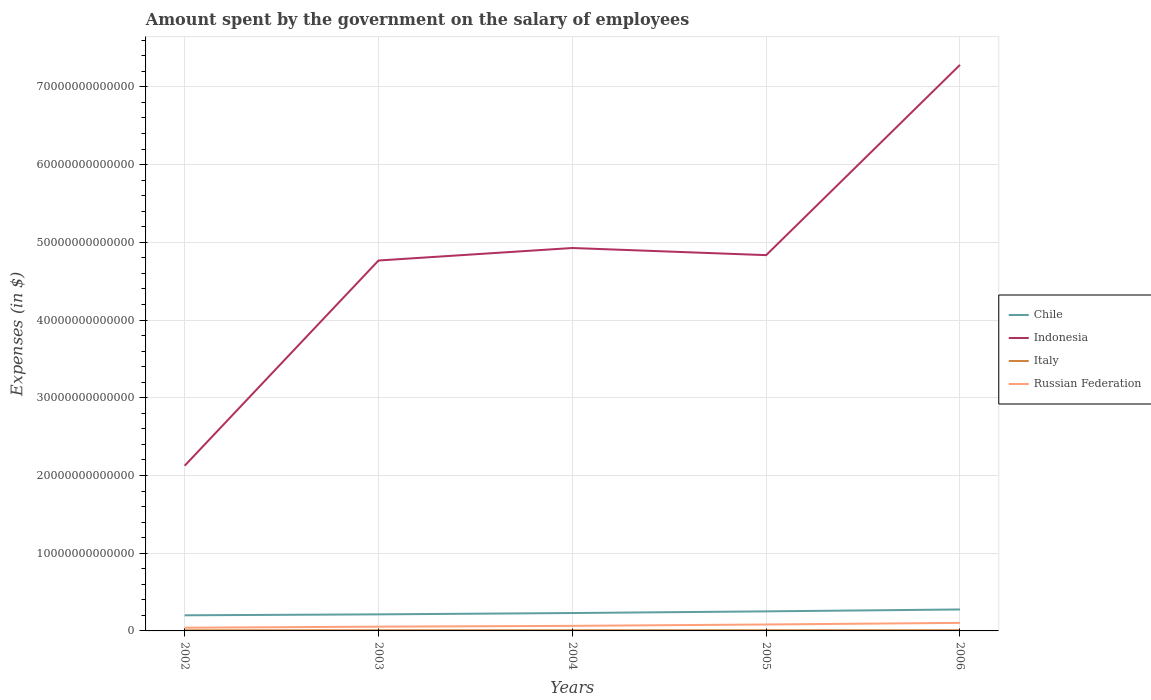How many different coloured lines are there?
Offer a terse response. 4. Does the line corresponding to Russian Federation intersect with the line corresponding to Indonesia?
Provide a short and direct response. No. Is the number of lines equal to the number of legend labels?
Provide a short and direct response. Yes. Across all years, what is the maximum amount spent on the salary of employees by the government in Chile?
Ensure brevity in your answer.  2.01e+12. In which year was the amount spent on the salary of employees by the government in Chile maximum?
Your answer should be compact. 2002. What is the total amount spent on the salary of employees by the government in Russian Federation in the graph?
Your answer should be compact. -4.15e+11. What is the difference between the highest and the second highest amount spent on the salary of employees by the government in Indonesia?
Your answer should be compact. 5.16e+13. Is the amount spent on the salary of employees by the government in Italy strictly greater than the amount spent on the salary of employees by the government in Chile over the years?
Your answer should be compact. Yes. How many years are there in the graph?
Your answer should be very brief. 5. What is the difference between two consecutive major ticks on the Y-axis?
Provide a succinct answer. 1.00e+13. Are the values on the major ticks of Y-axis written in scientific E-notation?
Your answer should be very brief. No. Where does the legend appear in the graph?
Keep it short and to the point. Center right. How many legend labels are there?
Your answer should be compact. 4. What is the title of the graph?
Make the answer very short. Amount spent by the government on the salary of employees. What is the label or title of the X-axis?
Make the answer very short. Years. What is the label or title of the Y-axis?
Ensure brevity in your answer.  Expenses (in $). What is the Expenses (in $) in Chile in 2002?
Give a very brief answer. 2.01e+12. What is the Expenses (in $) of Indonesia in 2002?
Offer a terse response. 2.13e+13. What is the Expenses (in $) of Italy in 2002?
Give a very brief answer. 8.01e+1. What is the Expenses (in $) of Russian Federation in 2002?
Provide a short and direct response. 4.13e+11. What is the Expenses (in $) of Chile in 2003?
Make the answer very short. 2.13e+12. What is the Expenses (in $) in Indonesia in 2003?
Make the answer very short. 4.77e+13. What is the Expenses (in $) in Italy in 2003?
Your answer should be compact. 8.59e+1. What is the Expenses (in $) in Russian Federation in 2003?
Give a very brief answer. 5.48e+11. What is the Expenses (in $) in Chile in 2004?
Your answer should be very brief. 2.30e+12. What is the Expenses (in $) in Indonesia in 2004?
Give a very brief answer. 4.93e+13. What is the Expenses (in $) in Italy in 2004?
Ensure brevity in your answer.  8.68e+1. What is the Expenses (in $) in Russian Federation in 2004?
Provide a succinct answer. 6.51e+11. What is the Expenses (in $) of Chile in 2005?
Offer a terse response. 2.52e+12. What is the Expenses (in $) of Indonesia in 2005?
Offer a very short reply. 4.84e+13. What is the Expenses (in $) of Italy in 2005?
Your answer should be compact. 9.12e+1. What is the Expenses (in $) of Russian Federation in 2005?
Your answer should be compact. 8.28e+11. What is the Expenses (in $) in Chile in 2006?
Keep it short and to the point. 2.76e+12. What is the Expenses (in $) of Indonesia in 2006?
Keep it short and to the point. 7.28e+13. What is the Expenses (in $) in Italy in 2006?
Offer a terse response. 9.31e+1. What is the Expenses (in $) in Russian Federation in 2006?
Offer a very short reply. 1.04e+12. Across all years, what is the maximum Expenses (in $) in Chile?
Offer a very short reply. 2.76e+12. Across all years, what is the maximum Expenses (in $) of Indonesia?
Your response must be concise. 7.28e+13. Across all years, what is the maximum Expenses (in $) of Italy?
Give a very brief answer. 9.31e+1. Across all years, what is the maximum Expenses (in $) of Russian Federation?
Offer a terse response. 1.04e+12. Across all years, what is the minimum Expenses (in $) of Chile?
Offer a very short reply. 2.01e+12. Across all years, what is the minimum Expenses (in $) of Indonesia?
Offer a very short reply. 2.13e+13. Across all years, what is the minimum Expenses (in $) in Italy?
Your response must be concise. 8.01e+1. Across all years, what is the minimum Expenses (in $) of Russian Federation?
Provide a succinct answer. 4.13e+11. What is the total Expenses (in $) in Chile in the graph?
Make the answer very short. 1.17e+13. What is the total Expenses (in $) in Indonesia in the graph?
Provide a short and direct response. 2.39e+14. What is the total Expenses (in $) in Italy in the graph?
Offer a terse response. 4.37e+11. What is the total Expenses (in $) of Russian Federation in the graph?
Make the answer very short. 3.48e+12. What is the difference between the Expenses (in $) of Chile in 2002 and that in 2003?
Keep it short and to the point. -1.19e+11. What is the difference between the Expenses (in $) in Indonesia in 2002 and that in 2003?
Offer a terse response. -2.64e+13. What is the difference between the Expenses (in $) in Italy in 2002 and that in 2003?
Provide a succinct answer. -5.79e+09. What is the difference between the Expenses (in $) of Russian Federation in 2002 and that in 2003?
Ensure brevity in your answer.  -1.35e+11. What is the difference between the Expenses (in $) in Chile in 2002 and that in 2004?
Your answer should be compact. -2.90e+11. What is the difference between the Expenses (in $) in Indonesia in 2002 and that in 2004?
Give a very brief answer. -2.80e+13. What is the difference between the Expenses (in $) in Italy in 2002 and that in 2004?
Provide a short and direct response. -6.71e+09. What is the difference between the Expenses (in $) of Russian Federation in 2002 and that in 2004?
Give a very brief answer. -2.38e+11. What is the difference between the Expenses (in $) of Chile in 2002 and that in 2005?
Offer a terse response. -5.07e+11. What is the difference between the Expenses (in $) in Indonesia in 2002 and that in 2005?
Give a very brief answer. -2.71e+13. What is the difference between the Expenses (in $) in Italy in 2002 and that in 2005?
Provide a short and direct response. -1.11e+1. What is the difference between the Expenses (in $) in Russian Federation in 2002 and that in 2005?
Your answer should be compact. -4.15e+11. What is the difference between the Expenses (in $) in Chile in 2002 and that in 2006?
Give a very brief answer. -7.49e+11. What is the difference between the Expenses (in $) in Indonesia in 2002 and that in 2006?
Provide a succinct answer. -5.16e+13. What is the difference between the Expenses (in $) in Italy in 2002 and that in 2006?
Your answer should be very brief. -1.30e+1. What is the difference between the Expenses (in $) of Russian Federation in 2002 and that in 2006?
Your response must be concise. -6.22e+11. What is the difference between the Expenses (in $) of Chile in 2003 and that in 2004?
Your answer should be compact. -1.71e+11. What is the difference between the Expenses (in $) in Indonesia in 2003 and that in 2004?
Provide a short and direct response. -1.61e+12. What is the difference between the Expenses (in $) of Italy in 2003 and that in 2004?
Your answer should be compact. -9.24e+08. What is the difference between the Expenses (in $) in Russian Federation in 2003 and that in 2004?
Your response must be concise. -1.03e+11. What is the difference between the Expenses (in $) in Chile in 2003 and that in 2005?
Offer a very short reply. -3.87e+11. What is the difference between the Expenses (in $) in Indonesia in 2003 and that in 2005?
Offer a terse response. -6.89e+11. What is the difference between the Expenses (in $) in Italy in 2003 and that in 2005?
Make the answer very short. -5.29e+09. What is the difference between the Expenses (in $) of Russian Federation in 2003 and that in 2005?
Provide a short and direct response. -2.80e+11. What is the difference between the Expenses (in $) of Chile in 2003 and that in 2006?
Offer a terse response. -6.29e+11. What is the difference between the Expenses (in $) of Indonesia in 2003 and that in 2006?
Keep it short and to the point. -2.52e+13. What is the difference between the Expenses (in $) of Italy in 2003 and that in 2006?
Your answer should be very brief. -7.26e+09. What is the difference between the Expenses (in $) of Russian Federation in 2003 and that in 2006?
Offer a terse response. -4.87e+11. What is the difference between the Expenses (in $) in Chile in 2004 and that in 2005?
Make the answer very short. -2.16e+11. What is the difference between the Expenses (in $) in Indonesia in 2004 and that in 2005?
Offer a terse response. 9.19e+11. What is the difference between the Expenses (in $) of Italy in 2004 and that in 2005?
Offer a very short reply. -4.36e+09. What is the difference between the Expenses (in $) in Russian Federation in 2004 and that in 2005?
Offer a terse response. -1.77e+11. What is the difference between the Expenses (in $) of Chile in 2004 and that in 2006?
Your answer should be compact. -4.58e+11. What is the difference between the Expenses (in $) in Indonesia in 2004 and that in 2006?
Keep it short and to the point. -2.36e+13. What is the difference between the Expenses (in $) in Italy in 2004 and that in 2006?
Offer a very short reply. -6.33e+09. What is the difference between the Expenses (in $) in Russian Federation in 2004 and that in 2006?
Your answer should be very brief. -3.84e+11. What is the difference between the Expenses (in $) of Chile in 2005 and that in 2006?
Offer a very short reply. -2.42e+11. What is the difference between the Expenses (in $) in Indonesia in 2005 and that in 2006?
Offer a very short reply. -2.45e+13. What is the difference between the Expenses (in $) of Italy in 2005 and that in 2006?
Offer a terse response. -1.97e+09. What is the difference between the Expenses (in $) in Russian Federation in 2005 and that in 2006?
Keep it short and to the point. -2.07e+11. What is the difference between the Expenses (in $) of Chile in 2002 and the Expenses (in $) of Indonesia in 2003?
Offer a terse response. -4.57e+13. What is the difference between the Expenses (in $) in Chile in 2002 and the Expenses (in $) in Italy in 2003?
Offer a terse response. 1.93e+12. What is the difference between the Expenses (in $) of Chile in 2002 and the Expenses (in $) of Russian Federation in 2003?
Your answer should be compact. 1.46e+12. What is the difference between the Expenses (in $) of Indonesia in 2002 and the Expenses (in $) of Italy in 2003?
Offer a terse response. 2.12e+13. What is the difference between the Expenses (in $) in Indonesia in 2002 and the Expenses (in $) in Russian Federation in 2003?
Your answer should be very brief. 2.07e+13. What is the difference between the Expenses (in $) of Italy in 2002 and the Expenses (in $) of Russian Federation in 2003?
Provide a succinct answer. -4.68e+11. What is the difference between the Expenses (in $) in Chile in 2002 and the Expenses (in $) in Indonesia in 2004?
Provide a succinct answer. -4.73e+13. What is the difference between the Expenses (in $) of Chile in 2002 and the Expenses (in $) of Italy in 2004?
Make the answer very short. 1.92e+12. What is the difference between the Expenses (in $) in Chile in 2002 and the Expenses (in $) in Russian Federation in 2004?
Your answer should be compact. 1.36e+12. What is the difference between the Expenses (in $) of Indonesia in 2002 and the Expenses (in $) of Italy in 2004?
Your response must be concise. 2.12e+13. What is the difference between the Expenses (in $) of Indonesia in 2002 and the Expenses (in $) of Russian Federation in 2004?
Ensure brevity in your answer.  2.06e+13. What is the difference between the Expenses (in $) in Italy in 2002 and the Expenses (in $) in Russian Federation in 2004?
Your answer should be compact. -5.71e+11. What is the difference between the Expenses (in $) of Chile in 2002 and the Expenses (in $) of Indonesia in 2005?
Make the answer very short. -4.63e+13. What is the difference between the Expenses (in $) of Chile in 2002 and the Expenses (in $) of Italy in 2005?
Offer a very short reply. 1.92e+12. What is the difference between the Expenses (in $) of Chile in 2002 and the Expenses (in $) of Russian Federation in 2005?
Your response must be concise. 1.18e+12. What is the difference between the Expenses (in $) in Indonesia in 2002 and the Expenses (in $) in Italy in 2005?
Offer a very short reply. 2.12e+13. What is the difference between the Expenses (in $) in Indonesia in 2002 and the Expenses (in $) in Russian Federation in 2005?
Your answer should be very brief. 2.04e+13. What is the difference between the Expenses (in $) of Italy in 2002 and the Expenses (in $) of Russian Federation in 2005?
Offer a very short reply. -7.48e+11. What is the difference between the Expenses (in $) of Chile in 2002 and the Expenses (in $) of Indonesia in 2006?
Give a very brief answer. -7.08e+13. What is the difference between the Expenses (in $) in Chile in 2002 and the Expenses (in $) in Italy in 2006?
Provide a succinct answer. 1.92e+12. What is the difference between the Expenses (in $) of Chile in 2002 and the Expenses (in $) of Russian Federation in 2006?
Give a very brief answer. 9.76e+11. What is the difference between the Expenses (in $) of Indonesia in 2002 and the Expenses (in $) of Italy in 2006?
Your answer should be compact. 2.12e+13. What is the difference between the Expenses (in $) of Indonesia in 2002 and the Expenses (in $) of Russian Federation in 2006?
Keep it short and to the point. 2.02e+13. What is the difference between the Expenses (in $) of Italy in 2002 and the Expenses (in $) of Russian Federation in 2006?
Keep it short and to the point. -9.55e+11. What is the difference between the Expenses (in $) in Chile in 2003 and the Expenses (in $) in Indonesia in 2004?
Keep it short and to the point. -4.71e+13. What is the difference between the Expenses (in $) of Chile in 2003 and the Expenses (in $) of Italy in 2004?
Offer a terse response. 2.04e+12. What is the difference between the Expenses (in $) of Chile in 2003 and the Expenses (in $) of Russian Federation in 2004?
Your answer should be compact. 1.48e+12. What is the difference between the Expenses (in $) of Indonesia in 2003 and the Expenses (in $) of Italy in 2004?
Your response must be concise. 4.76e+13. What is the difference between the Expenses (in $) in Indonesia in 2003 and the Expenses (in $) in Russian Federation in 2004?
Offer a very short reply. 4.70e+13. What is the difference between the Expenses (in $) in Italy in 2003 and the Expenses (in $) in Russian Federation in 2004?
Your answer should be compact. -5.65e+11. What is the difference between the Expenses (in $) in Chile in 2003 and the Expenses (in $) in Indonesia in 2005?
Make the answer very short. -4.62e+13. What is the difference between the Expenses (in $) in Chile in 2003 and the Expenses (in $) in Italy in 2005?
Keep it short and to the point. 2.04e+12. What is the difference between the Expenses (in $) of Chile in 2003 and the Expenses (in $) of Russian Federation in 2005?
Provide a short and direct response. 1.30e+12. What is the difference between the Expenses (in $) in Indonesia in 2003 and the Expenses (in $) in Italy in 2005?
Make the answer very short. 4.76e+13. What is the difference between the Expenses (in $) in Indonesia in 2003 and the Expenses (in $) in Russian Federation in 2005?
Your answer should be very brief. 4.68e+13. What is the difference between the Expenses (in $) of Italy in 2003 and the Expenses (in $) of Russian Federation in 2005?
Offer a very short reply. -7.42e+11. What is the difference between the Expenses (in $) of Chile in 2003 and the Expenses (in $) of Indonesia in 2006?
Offer a very short reply. -7.07e+13. What is the difference between the Expenses (in $) of Chile in 2003 and the Expenses (in $) of Italy in 2006?
Give a very brief answer. 2.04e+12. What is the difference between the Expenses (in $) of Chile in 2003 and the Expenses (in $) of Russian Federation in 2006?
Your answer should be very brief. 1.10e+12. What is the difference between the Expenses (in $) in Indonesia in 2003 and the Expenses (in $) in Italy in 2006?
Ensure brevity in your answer.  4.76e+13. What is the difference between the Expenses (in $) in Indonesia in 2003 and the Expenses (in $) in Russian Federation in 2006?
Provide a succinct answer. 4.66e+13. What is the difference between the Expenses (in $) in Italy in 2003 and the Expenses (in $) in Russian Federation in 2006?
Provide a succinct answer. -9.50e+11. What is the difference between the Expenses (in $) in Chile in 2004 and the Expenses (in $) in Indonesia in 2005?
Keep it short and to the point. -4.60e+13. What is the difference between the Expenses (in $) in Chile in 2004 and the Expenses (in $) in Italy in 2005?
Make the answer very short. 2.21e+12. What is the difference between the Expenses (in $) in Chile in 2004 and the Expenses (in $) in Russian Federation in 2005?
Provide a short and direct response. 1.47e+12. What is the difference between the Expenses (in $) of Indonesia in 2004 and the Expenses (in $) of Italy in 2005?
Give a very brief answer. 4.92e+13. What is the difference between the Expenses (in $) in Indonesia in 2004 and the Expenses (in $) in Russian Federation in 2005?
Your answer should be very brief. 4.84e+13. What is the difference between the Expenses (in $) in Italy in 2004 and the Expenses (in $) in Russian Federation in 2005?
Provide a succinct answer. -7.41e+11. What is the difference between the Expenses (in $) in Chile in 2004 and the Expenses (in $) in Indonesia in 2006?
Keep it short and to the point. -7.05e+13. What is the difference between the Expenses (in $) of Chile in 2004 and the Expenses (in $) of Italy in 2006?
Your response must be concise. 2.21e+12. What is the difference between the Expenses (in $) in Chile in 2004 and the Expenses (in $) in Russian Federation in 2006?
Your answer should be compact. 1.27e+12. What is the difference between the Expenses (in $) in Indonesia in 2004 and the Expenses (in $) in Italy in 2006?
Offer a terse response. 4.92e+13. What is the difference between the Expenses (in $) in Indonesia in 2004 and the Expenses (in $) in Russian Federation in 2006?
Keep it short and to the point. 4.82e+13. What is the difference between the Expenses (in $) of Italy in 2004 and the Expenses (in $) of Russian Federation in 2006?
Your answer should be very brief. -9.49e+11. What is the difference between the Expenses (in $) of Chile in 2005 and the Expenses (in $) of Indonesia in 2006?
Offer a terse response. -7.03e+13. What is the difference between the Expenses (in $) of Chile in 2005 and the Expenses (in $) of Italy in 2006?
Your response must be concise. 2.42e+12. What is the difference between the Expenses (in $) of Chile in 2005 and the Expenses (in $) of Russian Federation in 2006?
Make the answer very short. 1.48e+12. What is the difference between the Expenses (in $) of Indonesia in 2005 and the Expenses (in $) of Italy in 2006?
Offer a terse response. 4.83e+13. What is the difference between the Expenses (in $) in Indonesia in 2005 and the Expenses (in $) in Russian Federation in 2006?
Keep it short and to the point. 4.73e+13. What is the difference between the Expenses (in $) in Italy in 2005 and the Expenses (in $) in Russian Federation in 2006?
Offer a very short reply. -9.44e+11. What is the average Expenses (in $) in Chile per year?
Keep it short and to the point. 2.34e+12. What is the average Expenses (in $) in Indonesia per year?
Offer a very short reply. 4.79e+13. What is the average Expenses (in $) of Italy per year?
Your answer should be very brief. 8.74e+1. What is the average Expenses (in $) of Russian Federation per year?
Your response must be concise. 6.95e+11. In the year 2002, what is the difference between the Expenses (in $) in Chile and Expenses (in $) in Indonesia?
Your answer should be compact. -1.92e+13. In the year 2002, what is the difference between the Expenses (in $) of Chile and Expenses (in $) of Italy?
Ensure brevity in your answer.  1.93e+12. In the year 2002, what is the difference between the Expenses (in $) in Chile and Expenses (in $) in Russian Federation?
Provide a succinct answer. 1.60e+12. In the year 2002, what is the difference between the Expenses (in $) in Indonesia and Expenses (in $) in Italy?
Offer a terse response. 2.12e+13. In the year 2002, what is the difference between the Expenses (in $) in Indonesia and Expenses (in $) in Russian Federation?
Ensure brevity in your answer.  2.08e+13. In the year 2002, what is the difference between the Expenses (in $) in Italy and Expenses (in $) in Russian Federation?
Provide a succinct answer. -3.33e+11. In the year 2003, what is the difference between the Expenses (in $) in Chile and Expenses (in $) in Indonesia?
Your answer should be very brief. -4.55e+13. In the year 2003, what is the difference between the Expenses (in $) of Chile and Expenses (in $) of Italy?
Ensure brevity in your answer.  2.04e+12. In the year 2003, what is the difference between the Expenses (in $) of Chile and Expenses (in $) of Russian Federation?
Provide a succinct answer. 1.58e+12. In the year 2003, what is the difference between the Expenses (in $) of Indonesia and Expenses (in $) of Italy?
Offer a very short reply. 4.76e+13. In the year 2003, what is the difference between the Expenses (in $) in Indonesia and Expenses (in $) in Russian Federation?
Offer a terse response. 4.71e+13. In the year 2003, what is the difference between the Expenses (in $) of Italy and Expenses (in $) of Russian Federation?
Give a very brief answer. -4.62e+11. In the year 2004, what is the difference between the Expenses (in $) in Chile and Expenses (in $) in Indonesia?
Your response must be concise. -4.70e+13. In the year 2004, what is the difference between the Expenses (in $) of Chile and Expenses (in $) of Italy?
Keep it short and to the point. 2.21e+12. In the year 2004, what is the difference between the Expenses (in $) of Chile and Expenses (in $) of Russian Federation?
Make the answer very short. 1.65e+12. In the year 2004, what is the difference between the Expenses (in $) in Indonesia and Expenses (in $) in Italy?
Your answer should be very brief. 4.92e+13. In the year 2004, what is the difference between the Expenses (in $) in Indonesia and Expenses (in $) in Russian Federation?
Make the answer very short. 4.86e+13. In the year 2004, what is the difference between the Expenses (in $) of Italy and Expenses (in $) of Russian Federation?
Offer a terse response. -5.64e+11. In the year 2005, what is the difference between the Expenses (in $) in Chile and Expenses (in $) in Indonesia?
Your answer should be very brief. -4.58e+13. In the year 2005, what is the difference between the Expenses (in $) in Chile and Expenses (in $) in Italy?
Make the answer very short. 2.43e+12. In the year 2005, what is the difference between the Expenses (in $) of Chile and Expenses (in $) of Russian Federation?
Provide a succinct answer. 1.69e+12. In the year 2005, what is the difference between the Expenses (in $) of Indonesia and Expenses (in $) of Italy?
Keep it short and to the point. 4.83e+13. In the year 2005, what is the difference between the Expenses (in $) in Indonesia and Expenses (in $) in Russian Federation?
Offer a very short reply. 4.75e+13. In the year 2005, what is the difference between the Expenses (in $) in Italy and Expenses (in $) in Russian Federation?
Keep it short and to the point. -7.37e+11. In the year 2006, what is the difference between the Expenses (in $) in Chile and Expenses (in $) in Indonesia?
Offer a very short reply. -7.01e+13. In the year 2006, what is the difference between the Expenses (in $) of Chile and Expenses (in $) of Italy?
Provide a succinct answer. 2.67e+12. In the year 2006, what is the difference between the Expenses (in $) in Chile and Expenses (in $) in Russian Federation?
Make the answer very short. 1.72e+12. In the year 2006, what is the difference between the Expenses (in $) of Indonesia and Expenses (in $) of Italy?
Offer a very short reply. 7.27e+13. In the year 2006, what is the difference between the Expenses (in $) of Indonesia and Expenses (in $) of Russian Federation?
Give a very brief answer. 7.18e+13. In the year 2006, what is the difference between the Expenses (in $) of Italy and Expenses (in $) of Russian Federation?
Ensure brevity in your answer.  -9.42e+11. What is the ratio of the Expenses (in $) of Chile in 2002 to that in 2003?
Keep it short and to the point. 0.94. What is the ratio of the Expenses (in $) of Indonesia in 2002 to that in 2003?
Offer a terse response. 0.45. What is the ratio of the Expenses (in $) of Italy in 2002 to that in 2003?
Keep it short and to the point. 0.93. What is the ratio of the Expenses (in $) in Russian Federation in 2002 to that in 2003?
Make the answer very short. 0.75. What is the ratio of the Expenses (in $) of Chile in 2002 to that in 2004?
Provide a short and direct response. 0.87. What is the ratio of the Expenses (in $) of Indonesia in 2002 to that in 2004?
Give a very brief answer. 0.43. What is the ratio of the Expenses (in $) in Italy in 2002 to that in 2004?
Ensure brevity in your answer.  0.92. What is the ratio of the Expenses (in $) in Russian Federation in 2002 to that in 2004?
Offer a terse response. 0.63. What is the ratio of the Expenses (in $) in Chile in 2002 to that in 2005?
Give a very brief answer. 0.8. What is the ratio of the Expenses (in $) in Indonesia in 2002 to that in 2005?
Offer a very short reply. 0.44. What is the ratio of the Expenses (in $) in Italy in 2002 to that in 2005?
Provide a succinct answer. 0.88. What is the ratio of the Expenses (in $) in Russian Federation in 2002 to that in 2005?
Your response must be concise. 0.5. What is the ratio of the Expenses (in $) of Chile in 2002 to that in 2006?
Provide a short and direct response. 0.73. What is the ratio of the Expenses (in $) in Indonesia in 2002 to that in 2006?
Your response must be concise. 0.29. What is the ratio of the Expenses (in $) in Italy in 2002 to that in 2006?
Provide a succinct answer. 0.86. What is the ratio of the Expenses (in $) in Russian Federation in 2002 to that in 2006?
Give a very brief answer. 0.4. What is the ratio of the Expenses (in $) in Chile in 2003 to that in 2004?
Offer a terse response. 0.93. What is the ratio of the Expenses (in $) in Indonesia in 2003 to that in 2004?
Provide a succinct answer. 0.97. What is the ratio of the Expenses (in $) in Italy in 2003 to that in 2004?
Your answer should be compact. 0.99. What is the ratio of the Expenses (in $) in Russian Federation in 2003 to that in 2004?
Your answer should be compact. 0.84. What is the ratio of the Expenses (in $) of Chile in 2003 to that in 2005?
Your answer should be very brief. 0.85. What is the ratio of the Expenses (in $) in Indonesia in 2003 to that in 2005?
Your response must be concise. 0.99. What is the ratio of the Expenses (in $) in Italy in 2003 to that in 2005?
Your answer should be very brief. 0.94. What is the ratio of the Expenses (in $) in Russian Federation in 2003 to that in 2005?
Your answer should be very brief. 0.66. What is the ratio of the Expenses (in $) in Chile in 2003 to that in 2006?
Your answer should be very brief. 0.77. What is the ratio of the Expenses (in $) of Indonesia in 2003 to that in 2006?
Your response must be concise. 0.65. What is the ratio of the Expenses (in $) of Italy in 2003 to that in 2006?
Provide a short and direct response. 0.92. What is the ratio of the Expenses (in $) of Russian Federation in 2003 to that in 2006?
Provide a short and direct response. 0.53. What is the ratio of the Expenses (in $) in Chile in 2004 to that in 2005?
Make the answer very short. 0.91. What is the ratio of the Expenses (in $) in Indonesia in 2004 to that in 2005?
Offer a very short reply. 1.02. What is the ratio of the Expenses (in $) in Italy in 2004 to that in 2005?
Offer a terse response. 0.95. What is the ratio of the Expenses (in $) in Russian Federation in 2004 to that in 2005?
Keep it short and to the point. 0.79. What is the ratio of the Expenses (in $) in Chile in 2004 to that in 2006?
Give a very brief answer. 0.83. What is the ratio of the Expenses (in $) of Indonesia in 2004 to that in 2006?
Give a very brief answer. 0.68. What is the ratio of the Expenses (in $) in Italy in 2004 to that in 2006?
Make the answer very short. 0.93. What is the ratio of the Expenses (in $) in Russian Federation in 2004 to that in 2006?
Your response must be concise. 0.63. What is the ratio of the Expenses (in $) of Chile in 2005 to that in 2006?
Give a very brief answer. 0.91. What is the ratio of the Expenses (in $) of Indonesia in 2005 to that in 2006?
Give a very brief answer. 0.66. What is the ratio of the Expenses (in $) in Italy in 2005 to that in 2006?
Make the answer very short. 0.98. What is the ratio of the Expenses (in $) in Russian Federation in 2005 to that in 2006?
Provide a short and direct response. 0.8. What is the difference between the highest and the second highest Expenses (in $) in Chile?
Offer a very short reply. 2.42e+11. What is the difference between the highest and the second highest Expenses (in $) in Indonesia?
Offer a terse response. 2.36e+13. What is the difference between the highest and the second highest Expenses (in $) of Italy?
Offer a very short reply. 1.97e+09. What is the difference between the highest and the second highest Expenses (in $) of Russian Federation?
Make the answer very short. 2.07e+11. What is the difference between the highest and the lowest Expenses (in $) of Chile?
Your answer should be compact. 7.49e+11. What is the difference between the highest and the lowest Expenses (in $) of Indonesia?
Provide a short and direct response. 5.16e+13. What is the difference between the highest and the lowest Expenses (in $) in Italy?
Ensure brevity in your answer.  1.30e+1. What is the difference between the highest and the lowest Expenses (in $) of Russian Federation?
Make the answer very short. 6.22e+11. 